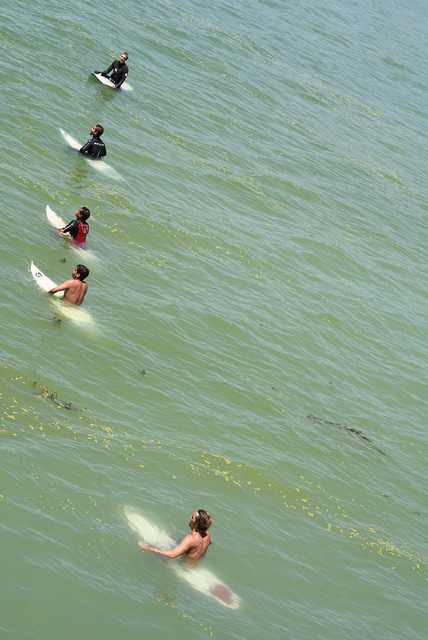Is there any wildlife visible in the water around the surfers? Yes, there appear to be patches of seaweed floating around the surfers, showcasing the natural habitat in which they are surfing. 